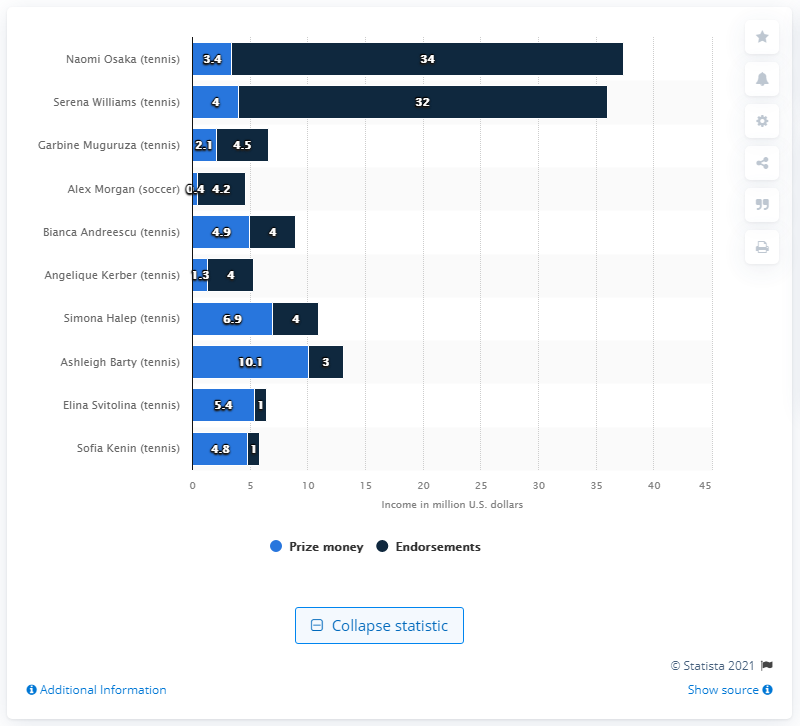Indicate a few pertinent items in this graphic. Ashleigh Barty, a professional tennis player, has earned the highest amount of prize money among all players. Naomi Osaka, a professional tennis player, has the highest income in endorsements among all players. 